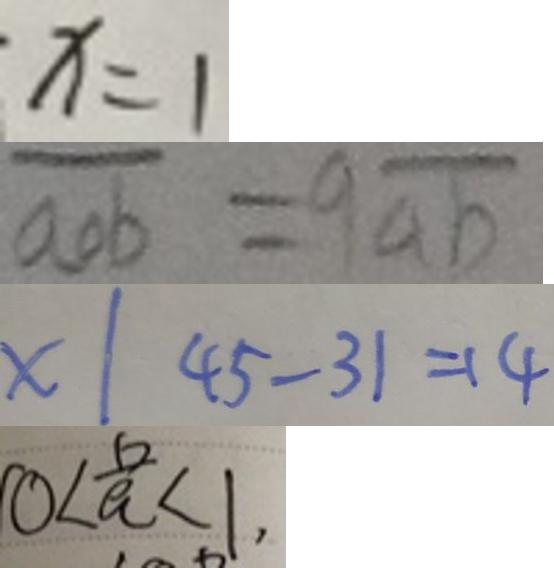<formula> <loc_0><loc_0><loc_500><loc_500>x = 1 
 \overline { a o b } = 9 \overline { a b } 
 x \vert 4 5 - 3 1 = 1 4 
 0 < \frac { 6 } { a } < 1 ,</formula> 